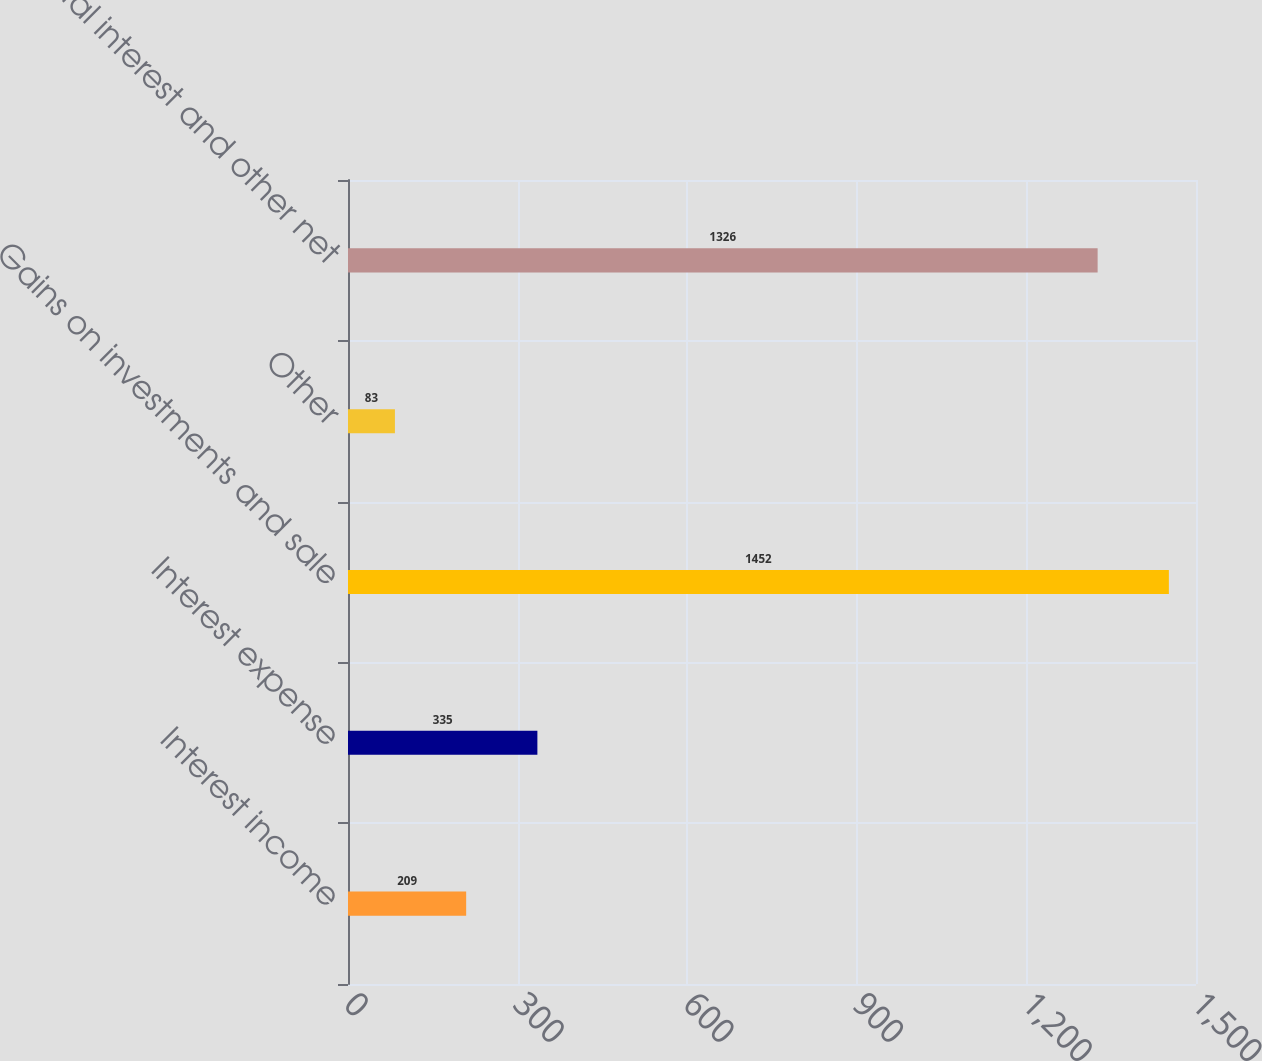<chart> <loc_0><loc_0><loc_500><loc_500><bar_chart><fcel>Interest income<fcel>Interest expense<fcel>Gains on investments and sale<fcel>Other<fcel>Total interest and other net<nl><fcel>209<fcel>335<fcel>1452<fcel>83<fcel>1326<nl></chart> 